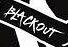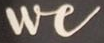What words are shown in these images in order, separated by a semicolon? BLACKOUT; We 